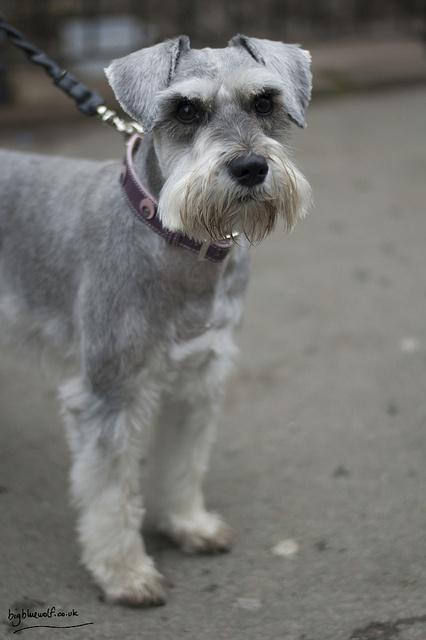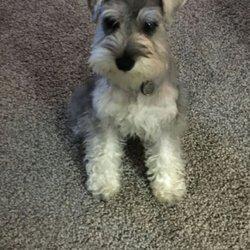The first image is the image on the left, the second image is the image on the right. For the images displayed, is the sentence "Greenery is visible in an image of a schnauzer." factually correct? Answer yes or no. No. 